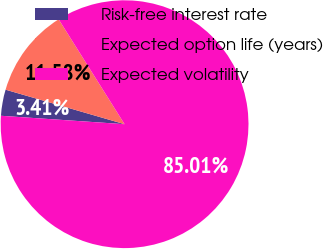<chart> <loc_0><loc_0><loc_500><loc_500><pie_chart><fcel>Risk-free interest rate<fcel>Expected option life (years)<fcel>Expected volatility<nl><fcel>3.41%<fcel>11.58%<fcel>85.02%<nl></chart> 